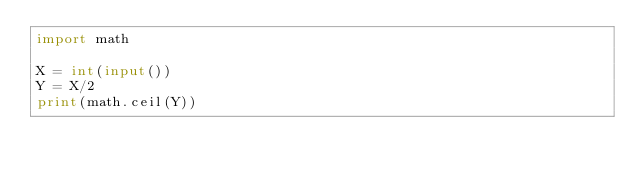Convert code to text. <code><loc_0><loc_0><loc_500><loc_500><_Python_>import math

X = int(input())
Y = X/2
print(math.ceil(Y))
</code> 